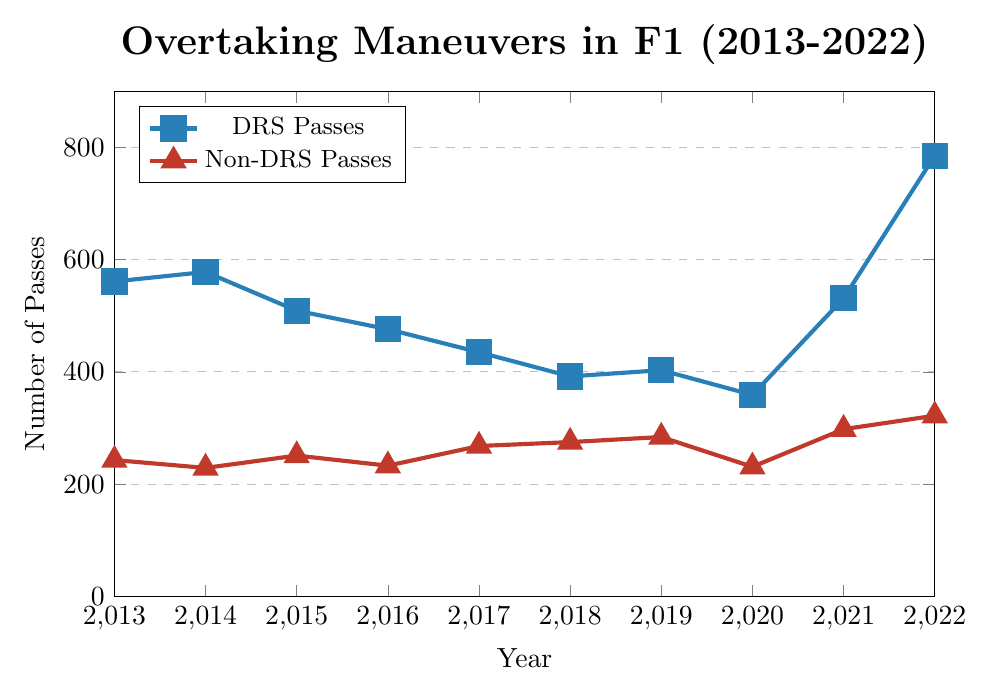Which year had the highest number of DRS passes? To find the year with the highest number of DRS passes, look at the data points on the blue line and identify the highest value. The peak on the blue line is at 2022 with 785 passes.
Answer: 2022 Which year had the lowest number of non-DRS passes? To find the year with the lowest number of non-DRS passes, examine the red line and find the lowest data point. The lowest value on the red line is at 2020 with 231 passes.
Answer: 2020 Compare the number of DRS and non-DRS passes in 2021. Which had more, and by how much? To compare 2021 values, look at the blue and red markers for that year. In 2021, the blue line (DRS passes) shows 531, and the red line (non-DRS passes) shows 298. The difference is 531 - 298 = 233.
Answer: DRS passes had 233 more What's the average number of DRS passes from 2013 to 2022? Sum all the DRS passes from 2013 to 2022 and divide by the number of years (10). Sum: 561 + 578 + 509 + 476 + 435 + 392 + 403 + 359 + 531 + 785 = 5029. Average: 5029 / 10 = 502.9
Answer: 502.9 By how much did the number of DRS passes increase from 2020 to 2022? To calculate the increase, subtract the value for 2020 from the value for 2022. In 2022, the number of DRS passes is 785, and in 2020 it is 359. The increase is 785 - 359 = 426.
Answer: 426 In which year was the difference between DRS passes and non-DRS passes the smallest? To find the smallest difference, calculate the absolute differences for each year and identify the minimum value. The differences are 318, 349, 258, 243, 167, 117, 119, 128, 233, and 463. The smallest difference is in 2018 with 117 passes.
Answer: 2018 How did the number of non-DRS passes change from 2013 to 2022? Observe the red line from 2013 to 2022. The number of non-DRS passes increased from 243 in 2013 to 322 in 2022.
Answer: The number increased What is the median number of DRS passes over the decade? List the DRS pass values in ascending order and find the median: 359, 392, 403, 435, 476, 509, 531, 561, 578, 785. The median is the average of the 5th and 6th values: (476 + 509) / 2 = 492.5.
Answer: 492.5 During which year did the number of DRS passes most closely match the number of non-DRS passes? Compare the numbers for each year and find the smallest difference. In 2018, DRS passes were 392 and non-DRS passes were 275, yielding the closest match with a difference of 117.
Answer: 2018 